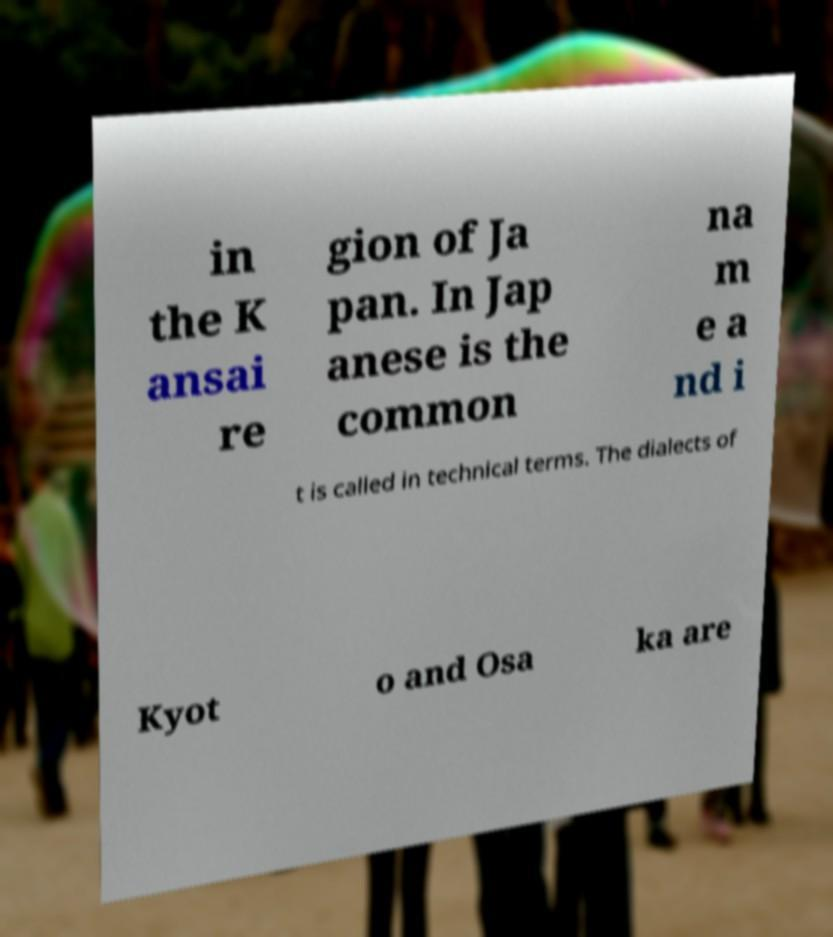Could you assist in decoding the text presented in this image and type it out clearly? in the K ansai re gion of Ja pan. In Jap anese is the common na m e a nd i t is called in technical terms. The dialects of Kyot o and Osa ka are 